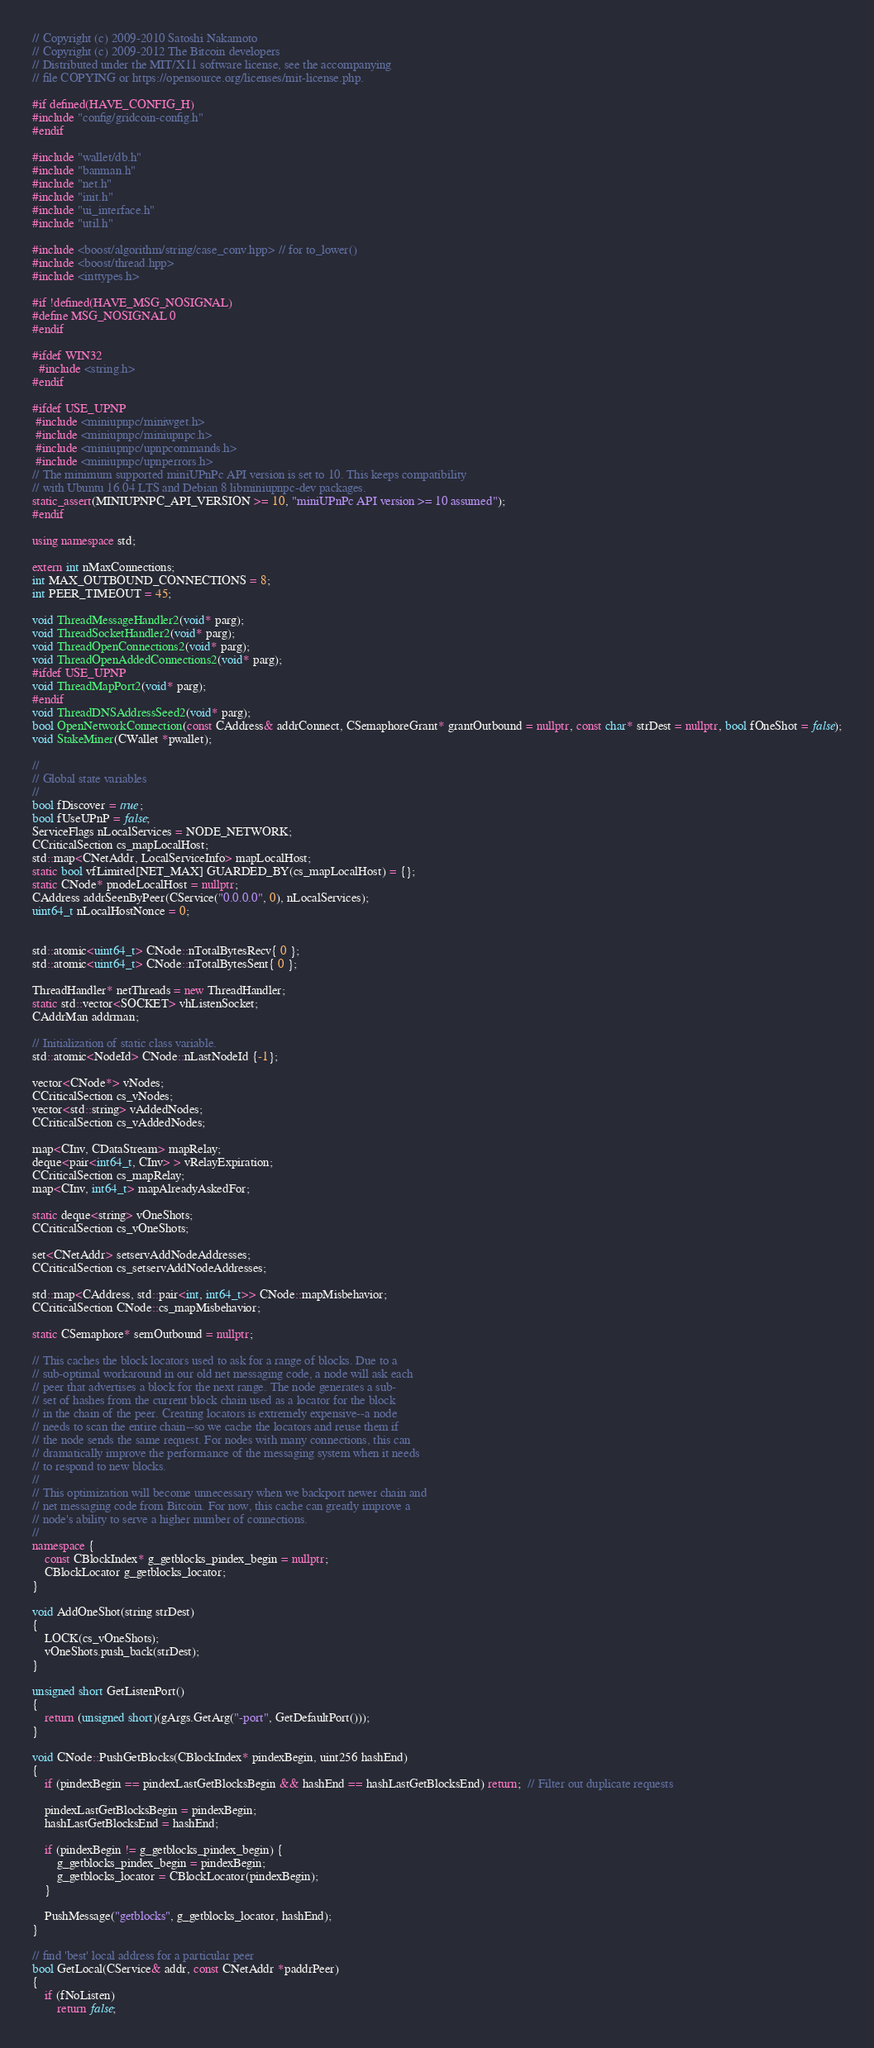Convert code to text. <code><loc_0><loc_0><loc_500><loc_500><_C++_>// Copyright (c) 2009-2010 Satoshi Nakamoto
// Copyright (c) 2009-2012 The Bitcoin developers
// Distributed under the MIT/X11 software license, see the accompanying
// file COPYING or https://opensource.org/licenses/mit-license.php.

#if defined(HAVE_CONFIG_H)
#include "config/gridcoin-config.h"
#endif

#include "wallet/db.h"
#include "banman.h"
#include "net.h"
#include "init.h"
#include "ui_interface.h"
#include "util.h"

#include <boost/algorithm/string/case_conv.hpp> // for to_lower()
#include <boost/thread.hpp>
#include <inttypes.h>

#if !defined(HAVE_MSG_NOSIGNAL)
#define MSG_NOSIGNAL 0
#endif

#ifdef WIN32
  #include <string.h>
#endif

#ifdef USE_UPNP
 #include <miniupnpc/miniwget.h>
 #include <miniupnpc/miniupnpc.h>
 #include <miniupnpc/upnpcommands.h>
 #include <miniupnpc/upnperrors.h>
// The minimum supported miniUPnPc API version is set to 10. This keeps compatibility
// with Ubuntu 16.04 LTS and Debian 8 libminiupnpc-dev packages.
static_assert(MINIUPNPC_API_VERSION >= 10, "miniUPnPc API version >= 10 assumed");
#endif

using namespace std;

extern int nMaxConnections;
int MAX_OUTBOUND_CONNECTIONS = 8;
int PEER_TIMEOUT = 45;

void ThreadMessageHandler2(void* parg);
void ThreadSocketHandler2(void* parg);
void ThreadOpenConnections2(void* parg);
void ThreadOpenAddedConnections2(void* parg);
#ifdef USE_UPNP
void ThreadMapPort2(void* parg);
#endif
void ThreadDNSAddressSeed2(void* parg);
bool OpenNetworkConnection(const CAddress& addrConnect, CSemaphoreGrant* grantOutbound = nullptr, const char* strDest = nullptr, bool fOneShot = false);
void StakeMiner(CWallet *pwallet);

//
// Global state variables
//
bool fDiscover = true;
bool fUseUPnP = false;
ServiceFlags nLocalServices = NODE_NETWORK;
CCriticalSection cs_mapLocalHost;
std::map<CNetAddr, LocalServiceInfo> mapLocalHost;
static bool vfLimited[NET_MAX] GUARDED_BY(cs_mapLocalHost) = {};
static CNode* pnodeLocalHost = nullptr;
CAddress addrSeenByPeer(CService("0.0.0.0", 0), nLocalServices);
uint64_t nLocalHostNonce = 0;


std::atomic<uint64_t> CNode::nTotalBytesRecv{ 0 };
std::atomic<uint64_t> CNode::nTotalBytesSent{ 0 };

ThreadHandler* netThreads = new ThreadHandler;
static std::vector<SOCKET> vhListenSocket;
CAddrMan addrman;

// Initialization of static class variable.
std::atomic<NodeId> CNode::nLastNodeId {-1};

vector<CNode*> vNodes;
CCriticalSection cs_vNodes;
vector<std::string> vAddedNodes;
CCriticalSection cs_vAddedNodes;

map<CInv, CDataStream> mapRelay;
deque<pair<int64_t, CInv> > vRelayExpiration;
CCriticalSection cs_mapRelay;
map<CInv, int64_t> mapAlreadyAskedFor;

static deque<string> vOneShots;
CCriticalSection cs_vOneShots;

set<CNetAddr> setservAddNodeAddresses;
CCriticalSection cs_setservAddNodeAddresses;

std::map<CAddress, std::pair<int, int64_t>> CNode::mapMisbehavior;
CCriticalSection CNode::cs_mapMisbehavior;

static CSemaphore* semOutbound = nullptr;

// This caches the block locators used to ask for a range of blocks. Due to a
// sub-optimal workaround in our old net messaging code, a node will ask each
// peer that advertises a block for the next range. The node generates a sub-
// set of hashes from the current block chain used as a locator for the block
// in the chain of the peer. Creating locators is extremely expensive--a node
// needs to scan the entire chain--so we cache the locators and reuse them if
// the node sends the same request. For nodes with many connections, this can
// dramatically improve the performance of the messaging system when it needs
// to respond to new blocks.
//
// This optimization will become unnecessary when we backport newer chain and
// net messaging code from Bitcoin. For now, this cache can greatly improve a
// node's ability to serve a higher number of connections.
//
namespace {
    const CBlockIndex* g_getblocks_pindex_begin = nullptr;
    CBlockLocator g_getblocks_locator;
}

void AddOneShot(string strDest)
{
    LOCK(cs_vOneShots);
    vOneShots.push_back(strDest);
}

unsigned short GetListenPort()
{
    return (unsigned short)(gArgs.GetArg("-port", GetDefaultPort()));
}

void CNode::PushGetBlocks(CBlockIndex* pindexBegin, uint256 hashEnd)
{
    if (pindexBegin == pindexLastGetBlocksBegin && hashEnd == hashLastGetBlocksEnd) return;  // Filter out duplicate requests

    pindexLastGetBlocksBegin = pindexBegin;
    hashLastGetBlocksEnd = hashEnd;

    if (pindexBegin != g_getblocks_pindex_begin) {
        g_getblocks_pindex_begin = pindexBegin;
        g_getblocks_locator = CBlockLocator(pindexBegin);
    }

    PushMessage("getblocks", g_getblocks_locator, hashEnd);
}

// find 'best' local address for a particular peer
bool GetLocal(CService& addr, const CNetAddr *paddrPeer)
{
    if (fNoListen)
        return false;
</code> 